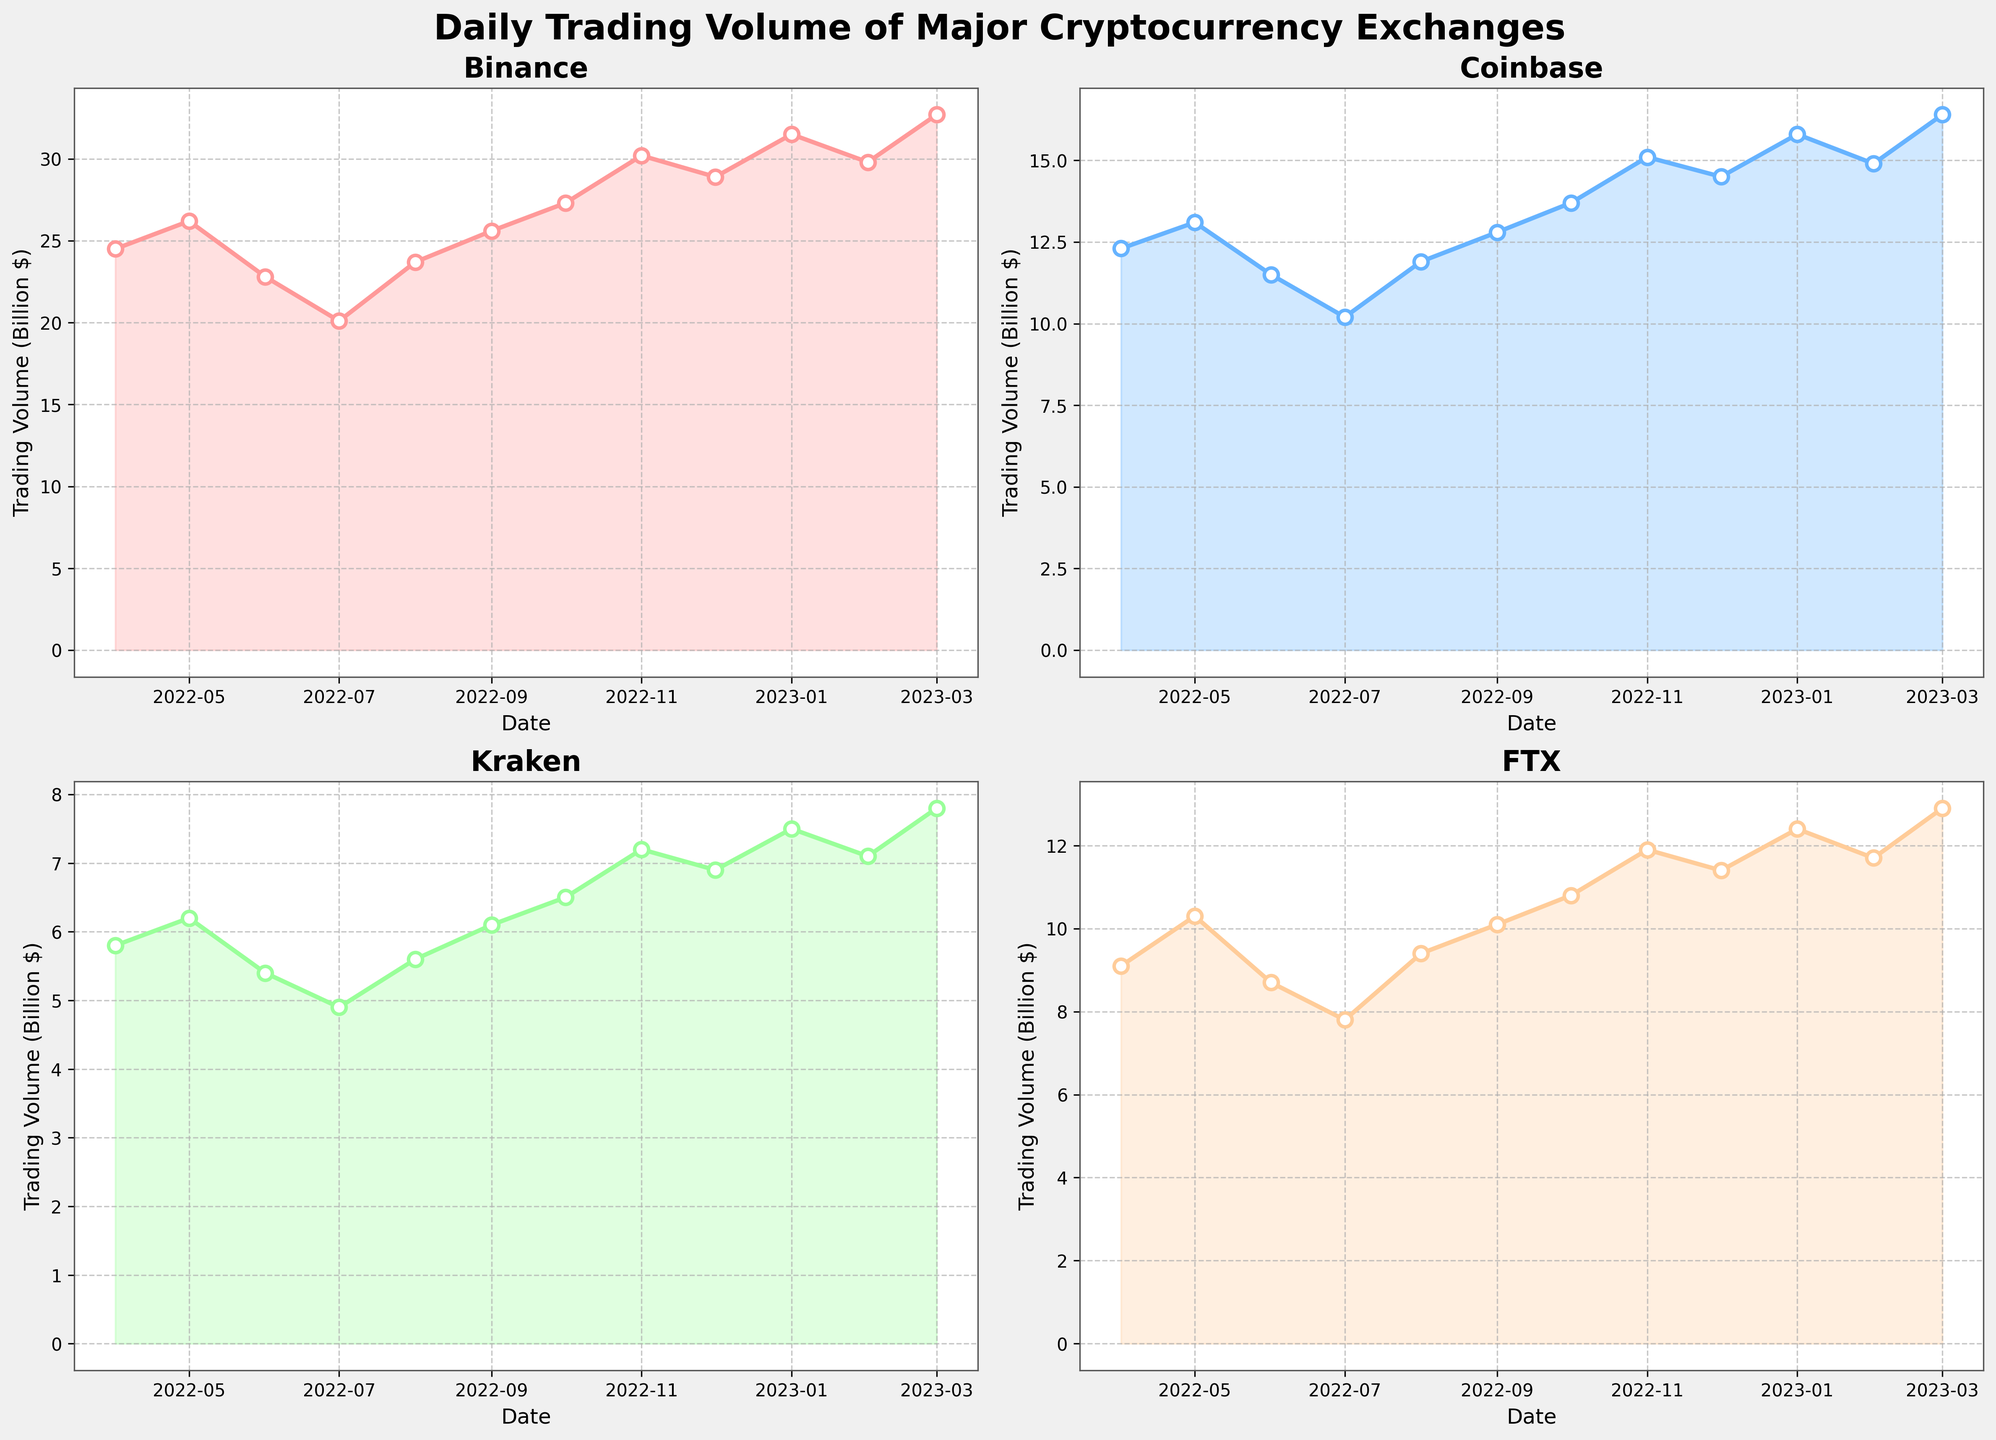How many different exchanges are plotted in this figure? The figure has subplots representing four different exchanges - Binance, Coinbase, Kraken, and FTX. Each subplot is labeled with the name of these exchanges.
Answer: 4 What is the title of the plot? The title of the plot is "Daily Trading Volume of Major Cryptocurrency Exchanges," which is displayed at the top of the figure in bold font.
Answer: Daily Trading Volume of Major Cryptocurrency Exchanges What is the highest trading volume observed for Binance? The highest trading volume for Binance can be observed by looking at the peak point in the Binance plot. The peak occurs in March 2023, with a value of 32.7 billion dollars.
Answer: 32.7 billion dollars Which exchange shows the lowest trading volume in June 2022? To find the lowest trading volume in June 2022, look at the values for each exchange on the date corresponding to June 2022. Kraken has the lowest value of 5.4 billion dollars.
Answer: Kraken In which month did FTX reach its peak trading volume? By examining the FTX subplot, the peak trading volume for FTX occurs in March 2023, marked by the highest point in that plot.
Answer: March 2023 What is the difference in trading volume between Binance and Coinbase in November 2022? The trading volume for Binance in November 2022 is 30.2 billion dollars, and for Coinbase, it's 15.1 billion dollars. The difference is calculated as 30.2 - 15.1 = 15.1 billion dollars.
Answer: 15.1 billion dollars Which exchange has the most significant increase in trading volume from January 2023 to March 2023? To determine this, compare the trading volumes for January and March 2023 for each exchange. Binance increased from 31.5 to 32.7 billion dollars, Coinbase from 15.8 to 16.4 billion dollars, Kraken from 7.5 to 7.8 billion dollars, and FTX from 12.4 to 12.9 billion dollars. Binance shows the highest increase of 1.2 billion dollars.
Answer: Binance How did the trading volume of Kraken change from April 2022 to December 2022? Examine the trading volumes for Kraken in April 2022 (5.8 billion dollars) and December 2022 (6.9 billion dollars). The change in trading volume is an increase of 6.9 - 5.8 = 1.1 billion dollars.
Answer: Increased by 1.1 billion dollars Which exchange had the most consistent trading volume throughout the year? To assess consistency, visually compare the lines of each exchange plot. Coinbase has the least fluctuation in its trading volume, indicating the most consistency among the exchanges.
Answer: Coinbase 